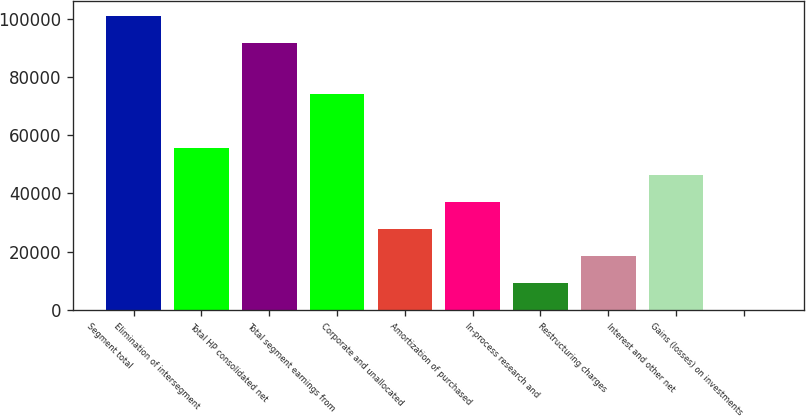Convert chart. <chart><loc_0><loc_0><loc_500><loc_500><bar_chart><fcel>Segment total<fcel>Elimination of intersegment<fcel>Total HP consolidated net<fcel>Total segment earnings from<fcel>Corporate and unallocated<fcel>Amortization of purchased<fcel>In-process research and<fcel>Restructuring charges<fcel>Interest and other net<fcel>Gains (losses) on investments<nl><fcel>100938<fcel>55703.2<fcel>91658<fcel>74262.6<fcel>27864.1<fcel>37143.8<fcel>9304.7<fcel>18584.4<fcel>46423.5<fcel>25<nl></chart> 